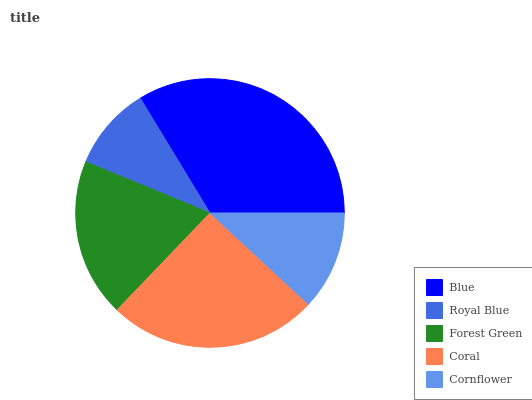Is Royal Blue the minimum?
Answer yes or no. Yes. Is Blue the maximum?
Answer yes or no. Yes. Is Forest Green the minimum?
Answer yes or no. No. Is Forest Green the maximum?
Answer yes or no. No. Is Forest Green greater than Royal Blue?
Answer yes or no. Yes. Is Royal Blue less than Forest Green?
Answer yes or no. Yes. Is Royal Blue greater than Forest Green?
Answer yes or no. No. Is Forest Green less than Royal Blue?
Answer yes or no. No. Is Forest Green the high median?
Answer yes or no. Yes. Is Forest Green the low median?
Answer yes or no. Yes. Is Cornflower the high median?
Answer yes or no. No. Is Royal Blue the low median?
Answer yes or no. No. 